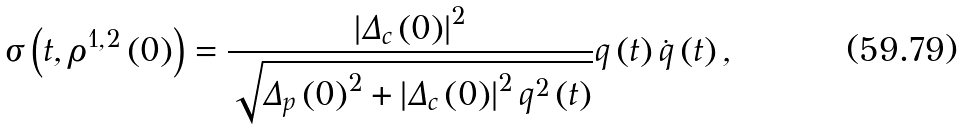Convert formula to latex. <formula><loc_0><loc_0><loc_500><loc_500>\sigma \left ( t , \rho ^ { 1 , 2 } \left ( 0 \right ) \right ) = \frac { \left | \Delta _ { c } \left ( 0 \right ) \right | ^ { 2 } } { \sqrt { \Delta _ { p } \left ( 0 \right ) ^ { 2 } + \left | \Delta _ { c } \left ( 0 \right ) \right | ^ { 2 } q ^ { 2 } \left ( t \right ) } } q \left ( t \right ) \dot { q } \left ( t \right ) ,</formula> 